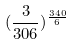Convert formula to latex. <formula><loc_0><loc_0><loc_500><loc_500>( \frac { 3 } { 3 0 6 } ) ^ { \frac { 3 4 0 } { 6 } }</formula> 